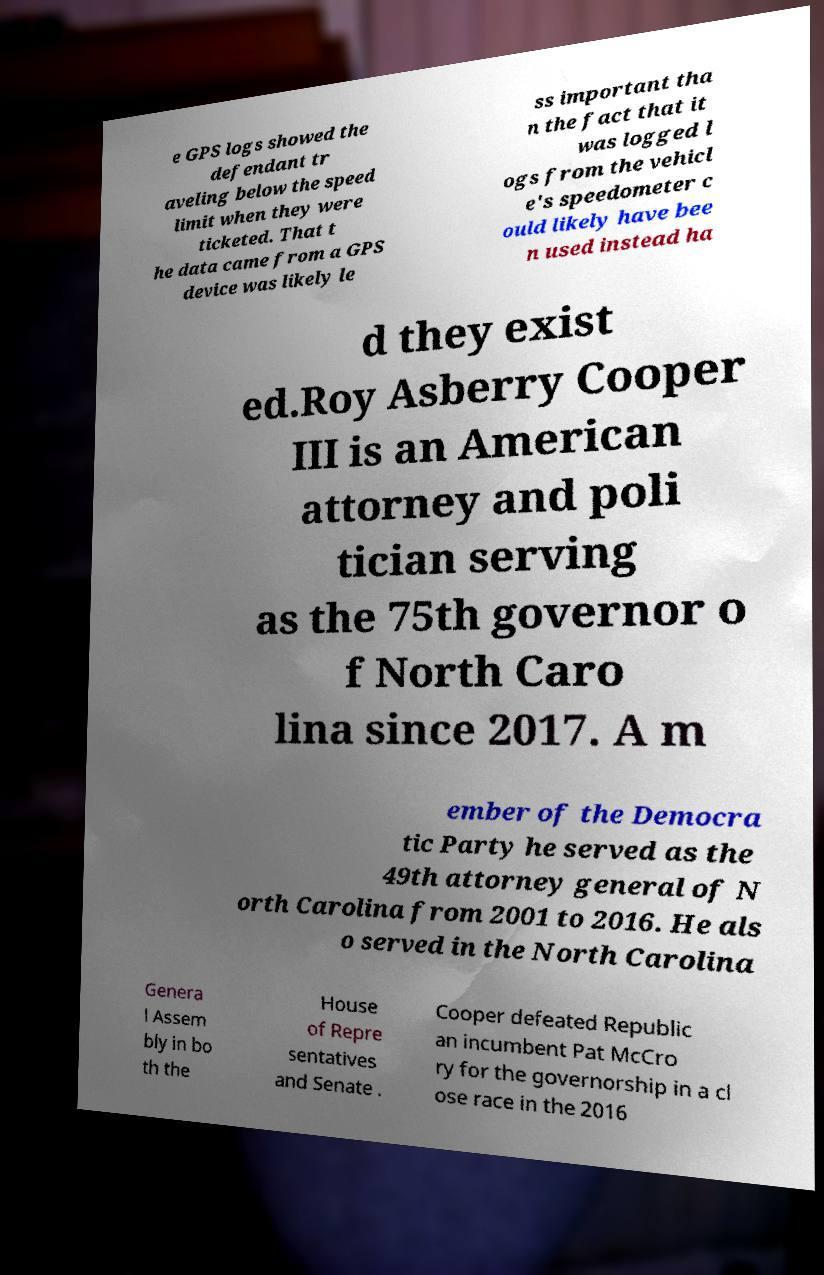Can you read and provide the text displayed in the image?This photo seems to have some interesting text. Can you extract and type it out for me? e GPS logs showed the defendant tr aveling below the speed limit when they were ticketed. That t he data came from a GPS device was likely le ss important tha n the fact that it was logged l ogs from the vehicl e's speedometer c ould likely have bee n used instead ha d they exist ed.Roy Asberry Cooper III is an American attorney and poli tician serving as the 75th governor o f North Caro lina since 2017. A m ember of the Democra tic Party he served as the 49th attorney general of N orth Carolina from 2001 to 2016. He als o served in the North Carolina Genera l Assem bly in bo th the House of Repre sentatives and Senate . Cooper defeated Republic an incumbent Pat McCro ry for the governorship in a cl ose race in the 2016 